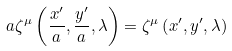<formula> <loc_0><loc_0><loc_500><loc_500>a \zeta ^ { \mu } \left ( { \frac { x ^ { \prime } } { a } , \frac { y ^ { \prime } } { a } , \lambda } \right ) = \zeta ^ { \mu } \left ( { x ^ { \prime } , y ^ { \prime } , \lambda } \right )</formula> 